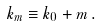<formula> <loc_0><loc_0><loc_500><loc_500>k _ { m } \equiv k _ { 0 } + m \, .</formula> 